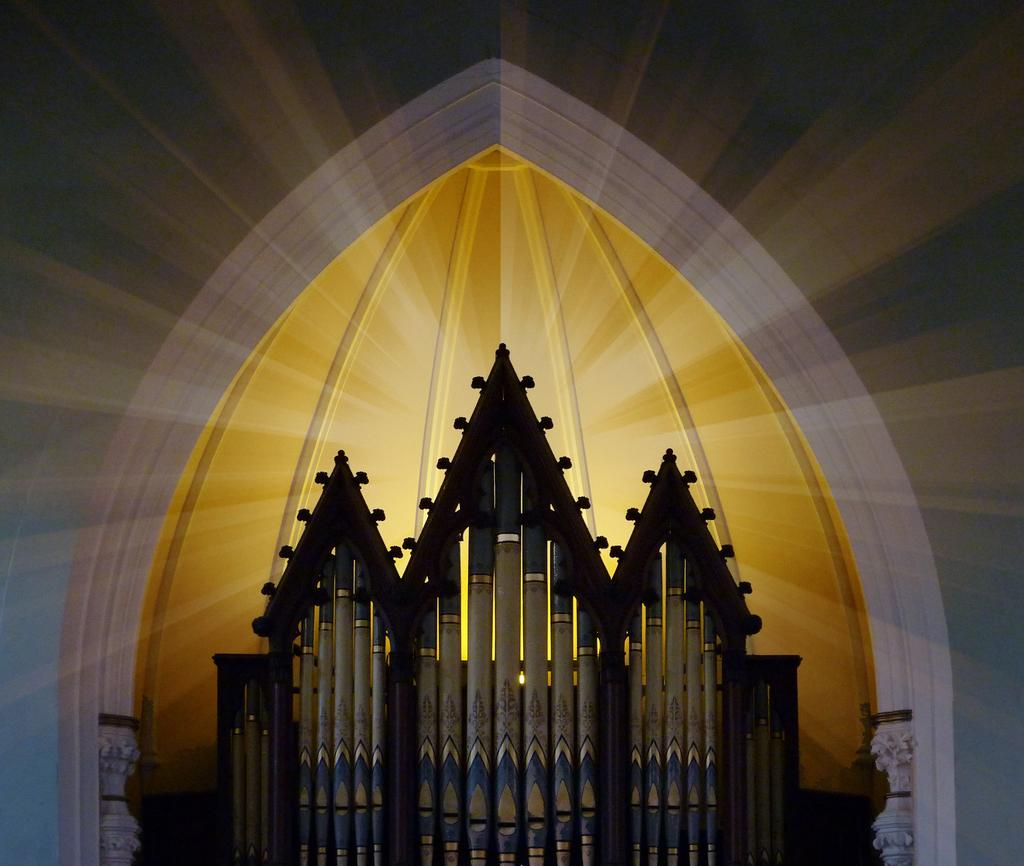What is located in the center of the image? There are metal pipes in the center of the image. What can be seen in the background of the image? There is light and a wall visible in the background of the image. What type of behavior can be observed in the quince in the image? There is no quince present in the image, so it is not possible to observe any behavior related to it. 